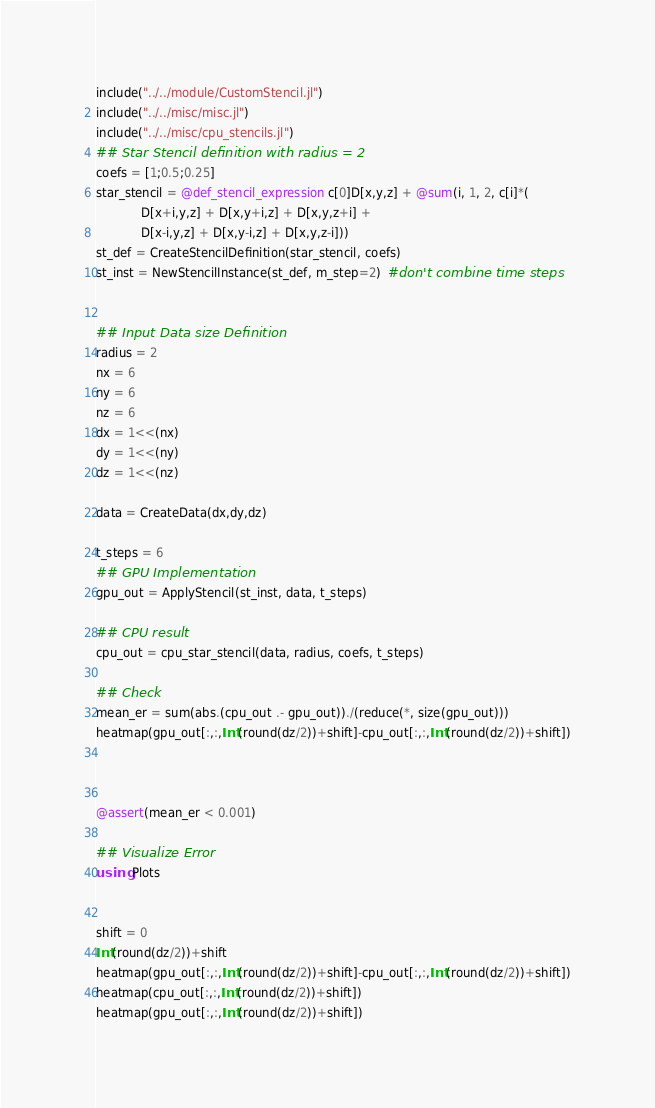Convert code to text. <code><loc_0><loc_0><loc_500><loc_500><_Julia_>include("../../module/CustomStencil.jl")
include("../../misc/misc.jl")
include("../../misc/cpu_stencils.jl")
## Star Stencil definition with radius = 2
coefs = [1;0.5;0.25]
star_stencil = @def_stencil_expression c[0]D[x,y,z] + @sum(i, 1, 2, c[i]*(
            D[x+i,y,z] + D[x,y+i,z] + D[x,y,z+i] +
            D[x-i,y,z] + D[x,y-i,z] + D[x,y,z-i]))
st_def = CreateStencilDefinition(star_stencil, coefs)
st_inst = NewStencilInstance(st_def, m_step=2)  #don't combine time steps


## Input Data size Definition
radius = 2
nx = 6
ny = 6
nz = 6
dx = 1<<(nx)
dy = 1<<(ny)
dz = 1<<(nz)

data = CreateData(dx,dy,dz)

t_steps = 6
## GPU Implementation
gpu_out = ApplyStencil(st_inst, data, t_steps)

## CPU result
cpu_out = cpu_star_stencil(data, radius, coefs, t_steps)

## Check
mean_er = sum(abs.(cpu_out .- gpu_out))./(reduce(*, size(gpu_out)))
heatmap(gpu_out[:,:,Int(round(dz/2))+shift]-cpu_out[:,:,Int(round(dz/2))+shift])



@assert(mean_er < 0.001)

## Visualize Error
using Plots


shift = 0
Int(round(dz/2))+shift
heatmap(gpu_out[:,:,Int(round(dz/2))+shift]-cpu_out[:,:,Int(round(dz/2))+shift])
heatmap(cpu_out[:,:,Int(round(dz/2))+shift])
heatmap(gpu_out[:,:,Int(round(dz/2))+shift])
</code> 